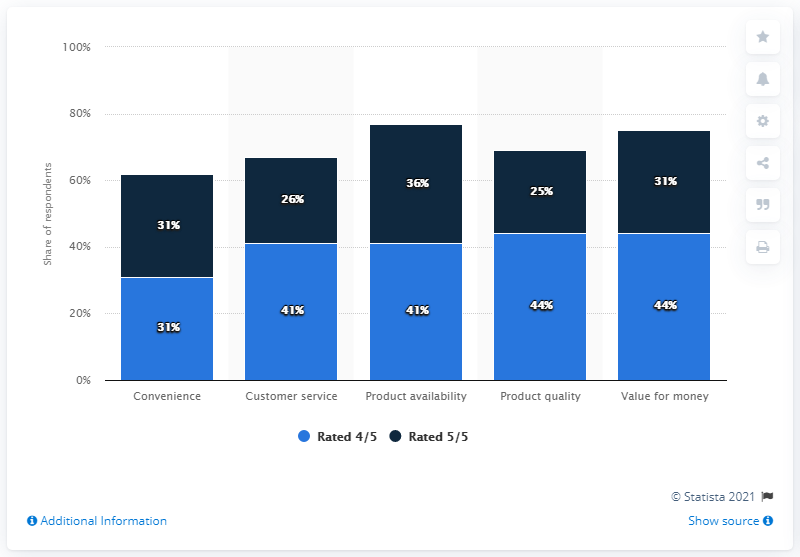Identify some key points in this picture. The mode of the rating "Rated 5/5" is 31. The color navy blue indicates high quality and a perfect rating of 5 out of 5. 